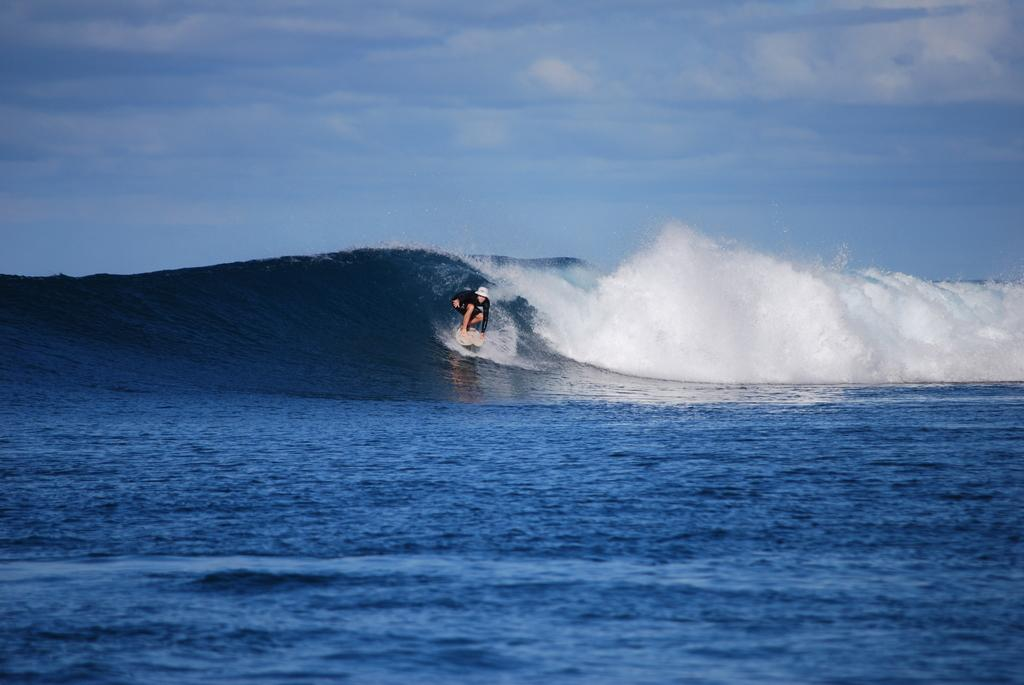What is the main subject of the image? There is a person in the image. What is the person doing in the image? The person is surfing on the water. What can be seen in the sky in the image? The sky is visible at the top of the image, and there are clouds in the sky. What is present at the bottom of the image? Water is present at the bottom of the image. What type of mist can be seen surrounding the person while they are surfing in the image? There is no mist present in the image; it features a person surfing on the water with a visible sky and clouds. 